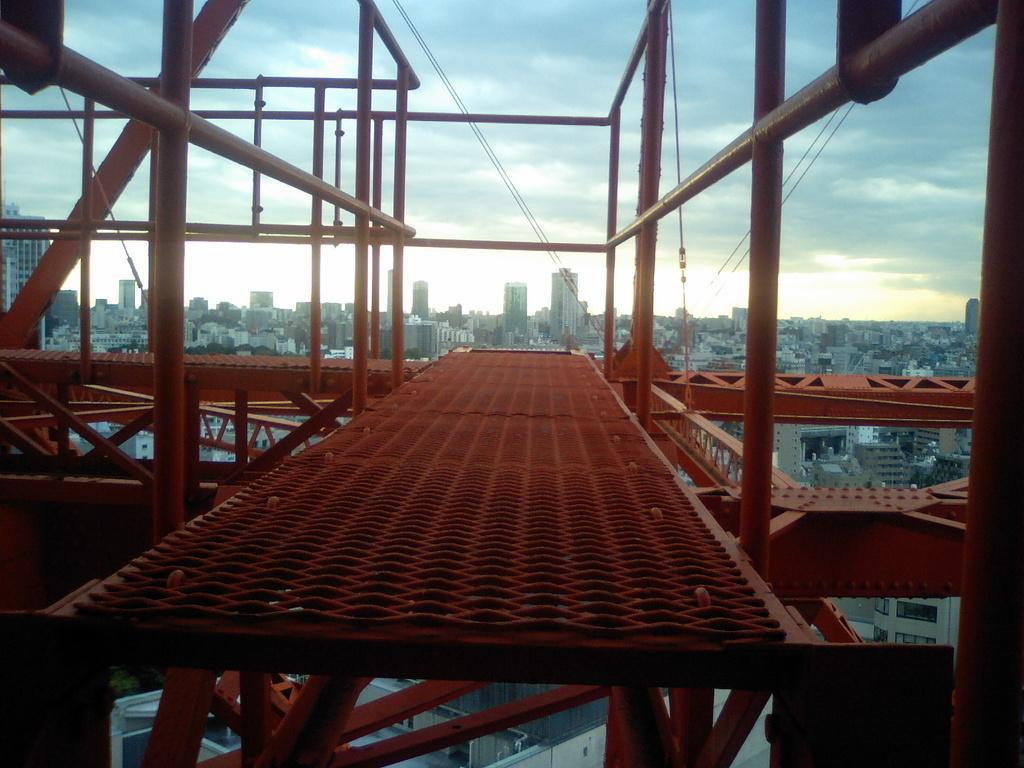What is happening in the image? There is construction of a building in the image. What materials are being used for the construction? The construction includes rods and poles. What can be seen in the background of the image? There are many buildings in the background of various sizes in the background of the image. What is visible in the sky in the image? The sky is visible in the image, and there are clouds in the sky. Can you tell me how many snakes are slithering around the construction site in the image? There are no snakes present in the image; it shows a construction site with rods and poles. What type of hospital is depicted in the image? There is no hospital depicted in the image; it features a construction site for a building. 